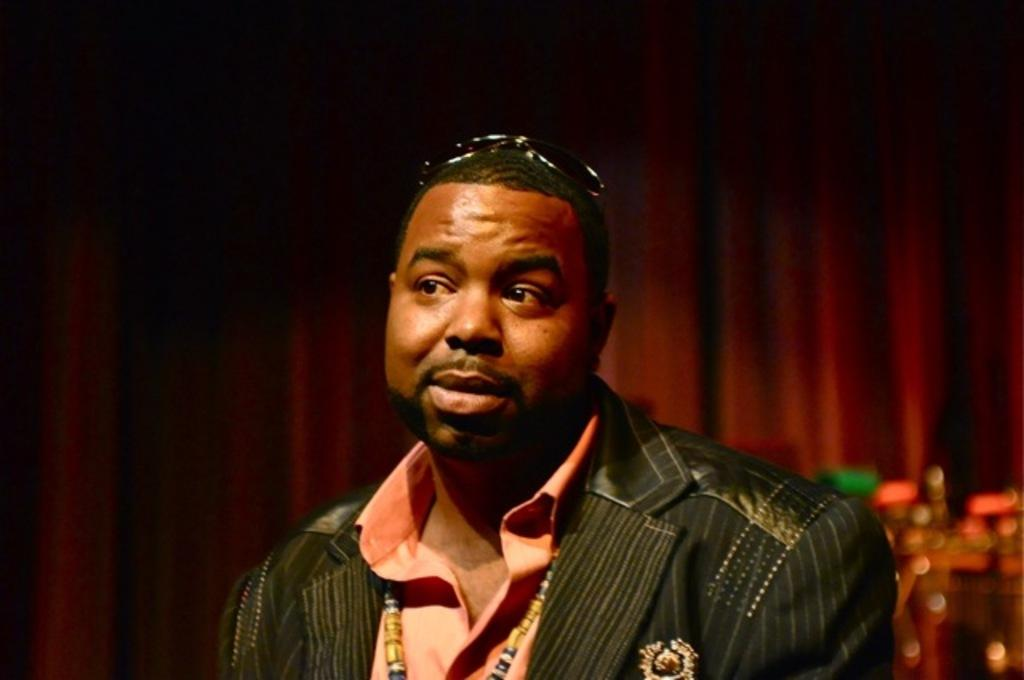Who or what is in the image? There is a person in the image. What is the person wearing? The person is wearing a black and orange dress. Can you describe the background of the image? There are objects in the background of the image, including a maroon color curtain. What type of mask is the person wearing in the image? There is no mask visible in the image; the person is wearing a black and orange dress. How is the person measuring the distance between objects in the image? There is no indication in the image that the person is measuring anything; they are simply standing there wearing a dress. 